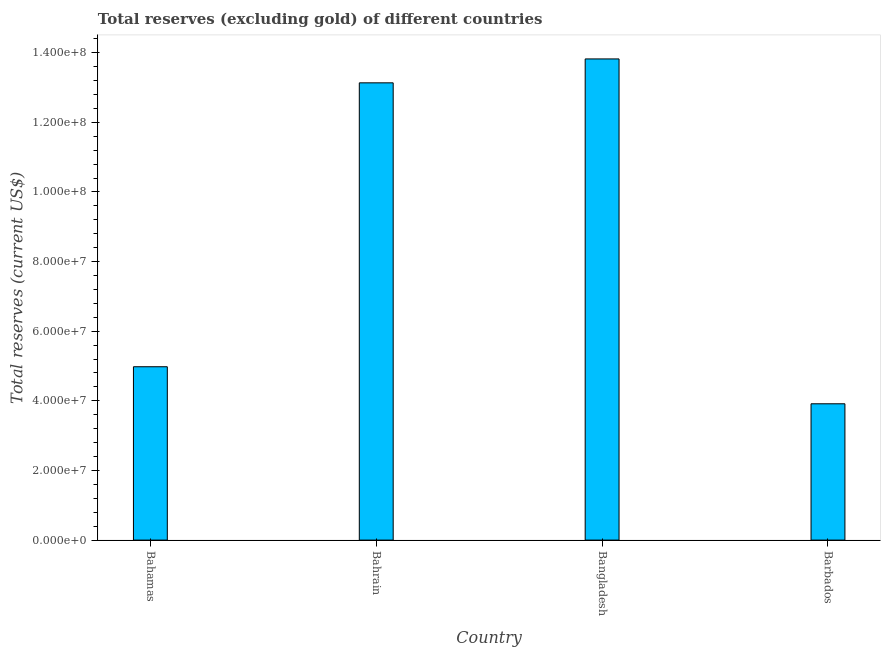Does the graph contain any zero values?
Provide a succinct answer. No. Does the graph contain grids?
Provide a succinct answer. No. What is the title of the graph?
Your answer should be very brief. Total reserves (excluding gold) of different countries. What is the label or title of the X-axis?
Offer a very short reply. Country. What is the label or title of the Y-axis?
Your response must be concise. Total reserves (current US$). What is the total reserves (excluding gold) in Bahrain?
Keep it short and to the point. 1.31e+08. Across all countries, what is the maximum total reserves (excluding gold)?
Give a very brief answer. 1.38e+08. Across all countries, what is the minimum total reserves (excluding gold)?
Make the answer very short. 3.92e+07. In which country was the total reserves (excluding gold) minimum?
Your response must be concise. Barbados. What is the sum of the total reserves (excluding gold)?
Make the answer very short. 3.58e+08. What is the difference between the total reserves (excluding gold) in Bahrain and Barbados?
Provide a short and direct response. 9.22e+07. What is the average total reserves (excluding gold) per country?
Offer a terse response. 8.96e+07. What is the median total reserves (excluding gold)?
Make the answer very short. 9.06e+07. What is the difference between the highest and the second highest total reserves (excluding gold)?
Your answer should be very brief. 6.87e+06. What is the difference between the highest and the lowest total reserves (excluding gold)?
Give a very brief answer. 9.90e+07. What is the difference between two consecutive major ticks on the Y-axis?
Your answer should be very brief. 2.00e+07. Are the values on the major ticks of Y-axis written in scientific E-notation?
Make the answer very short. Yes. What is the Total reserves (current US$) in Bahamas?
Your answer should be compact. 4.98e+07. What is the Total reserves (current US$) of Bahrain?
Offer a terse response. 1.31e+08. What is the Total reserves (current US$) in Bangladesh?
Your answer should be compact. 1.38e+08. What is the Total reserves (current US$) of Barbados?
Give a very brief answer. 3.92e+07. What is the difference between the Total reserves (current US$) in Bahamas and Bahrain?
Give a very brief answer. -8.15e+07. What is the difference between the Total reserves (current US$) in Bahamas and Bangladesh?
Offer a terse response. -8.84e+07. What is the difference between the Total reserves (current US$) in Bahamas and Barbados?
Provide a short and direct response. 1.06e+07. What is the difference between the Total reserves (current US$) in Bahrain and Bangladesh?
Provide a succinct answer. -6.87e+06. What is the difference between the Total reserves (current US$) in Bahrain and Barbados?
Ensure brevity in your answer.  9.22e+07. What is the difference between the Total reserves (current US$) in Bangladesh and Barbados?
Provide a succinct answer. 9.90e+07. What is the ratio of the Total reserves (current US$) in Bahamas to that in Bahrain?
Give a very brief answer. 0.38. What is the ratio of the Total reserves (current US$) in Bahamas to that in Bangladesh?
Make the answer very short. 0.36. What is the ratio of the Total reserves (current US$) in Bahamas to that in Barbados?
Your answer should be compact. 1.27. What is the ratio of the Total reserves (current US$) in Bahrain to that in Barbados?
Your response must be concise. 3.35. What is the ratio of the Total reserves (current US$) in Bangladesh to that in Barbados?
Make the answer very short. 3.53. 